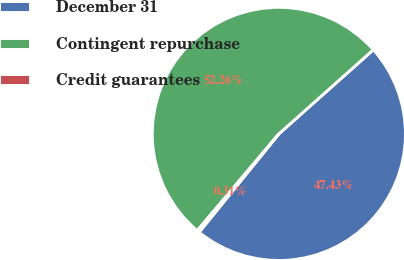Convert chart. <chart><loc_0><loc_0><loc_500><loc_500><pie_chart><fcel>December 31<fcel>Contingent repurchase<fcel>Credit guarantees<nl><fcel>47.43%<fcel>52.27%<fcel>0.31%<nl></chart> 